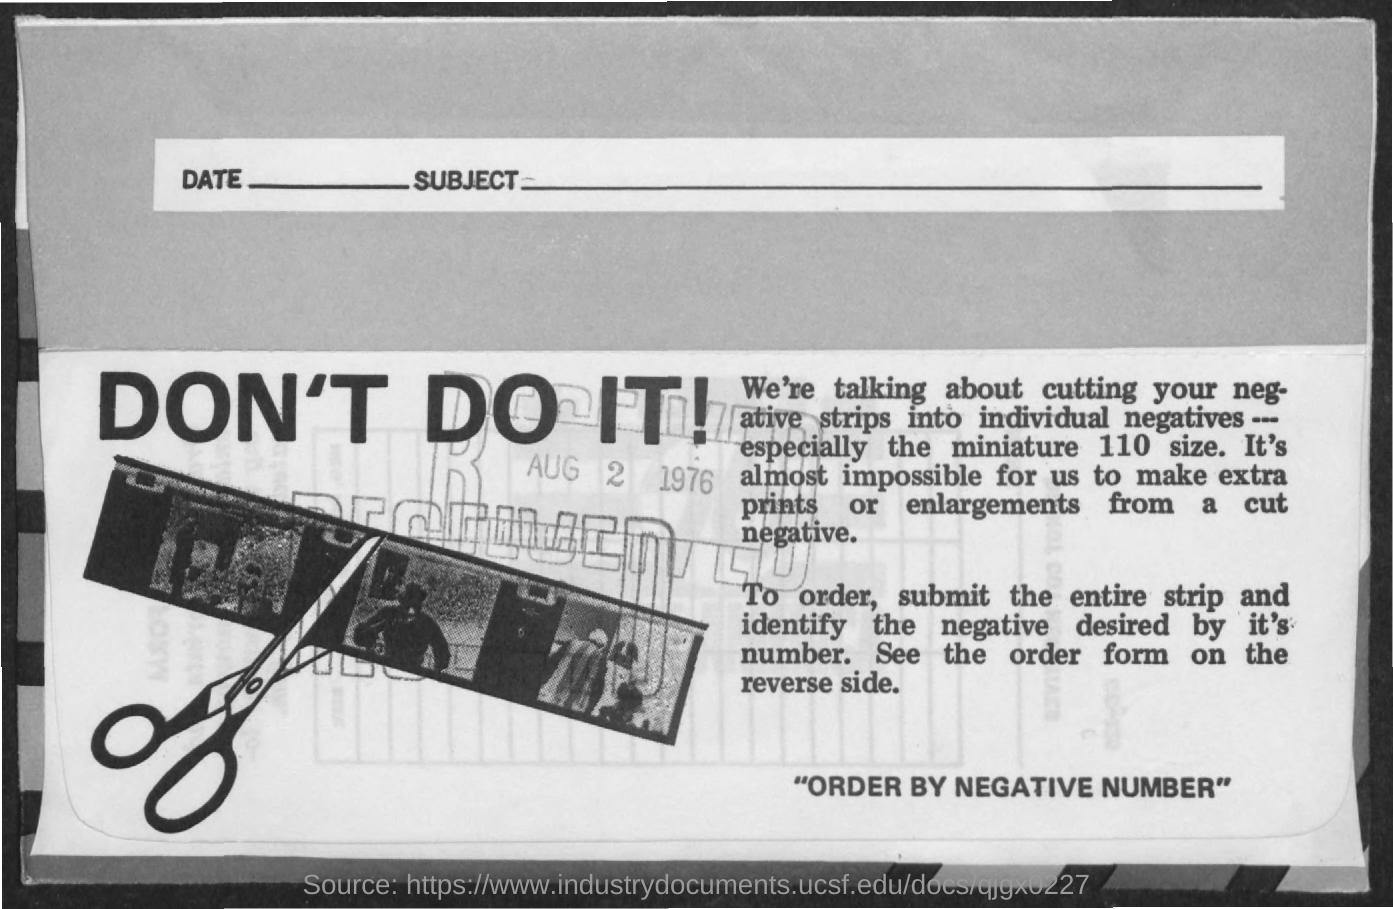What is the date received?
Your response must be concise. AUG 2 1976. 